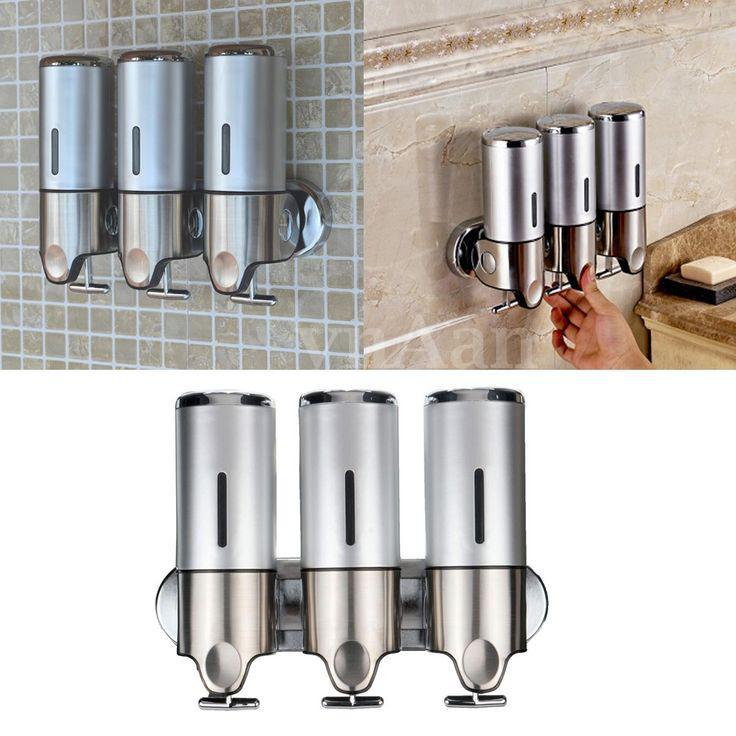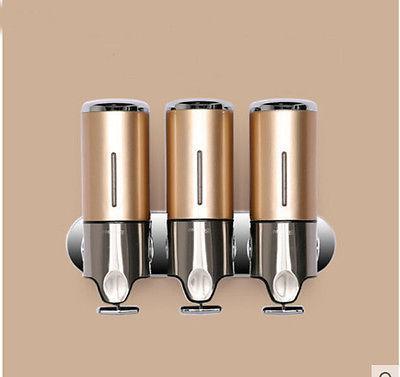The first image is the image on the left, the second image is the image on the right. Evaluate the accuracy of this statement regarding the images: "The left image contains a human hand.". Is it true? Answer yes or no. Yes. 